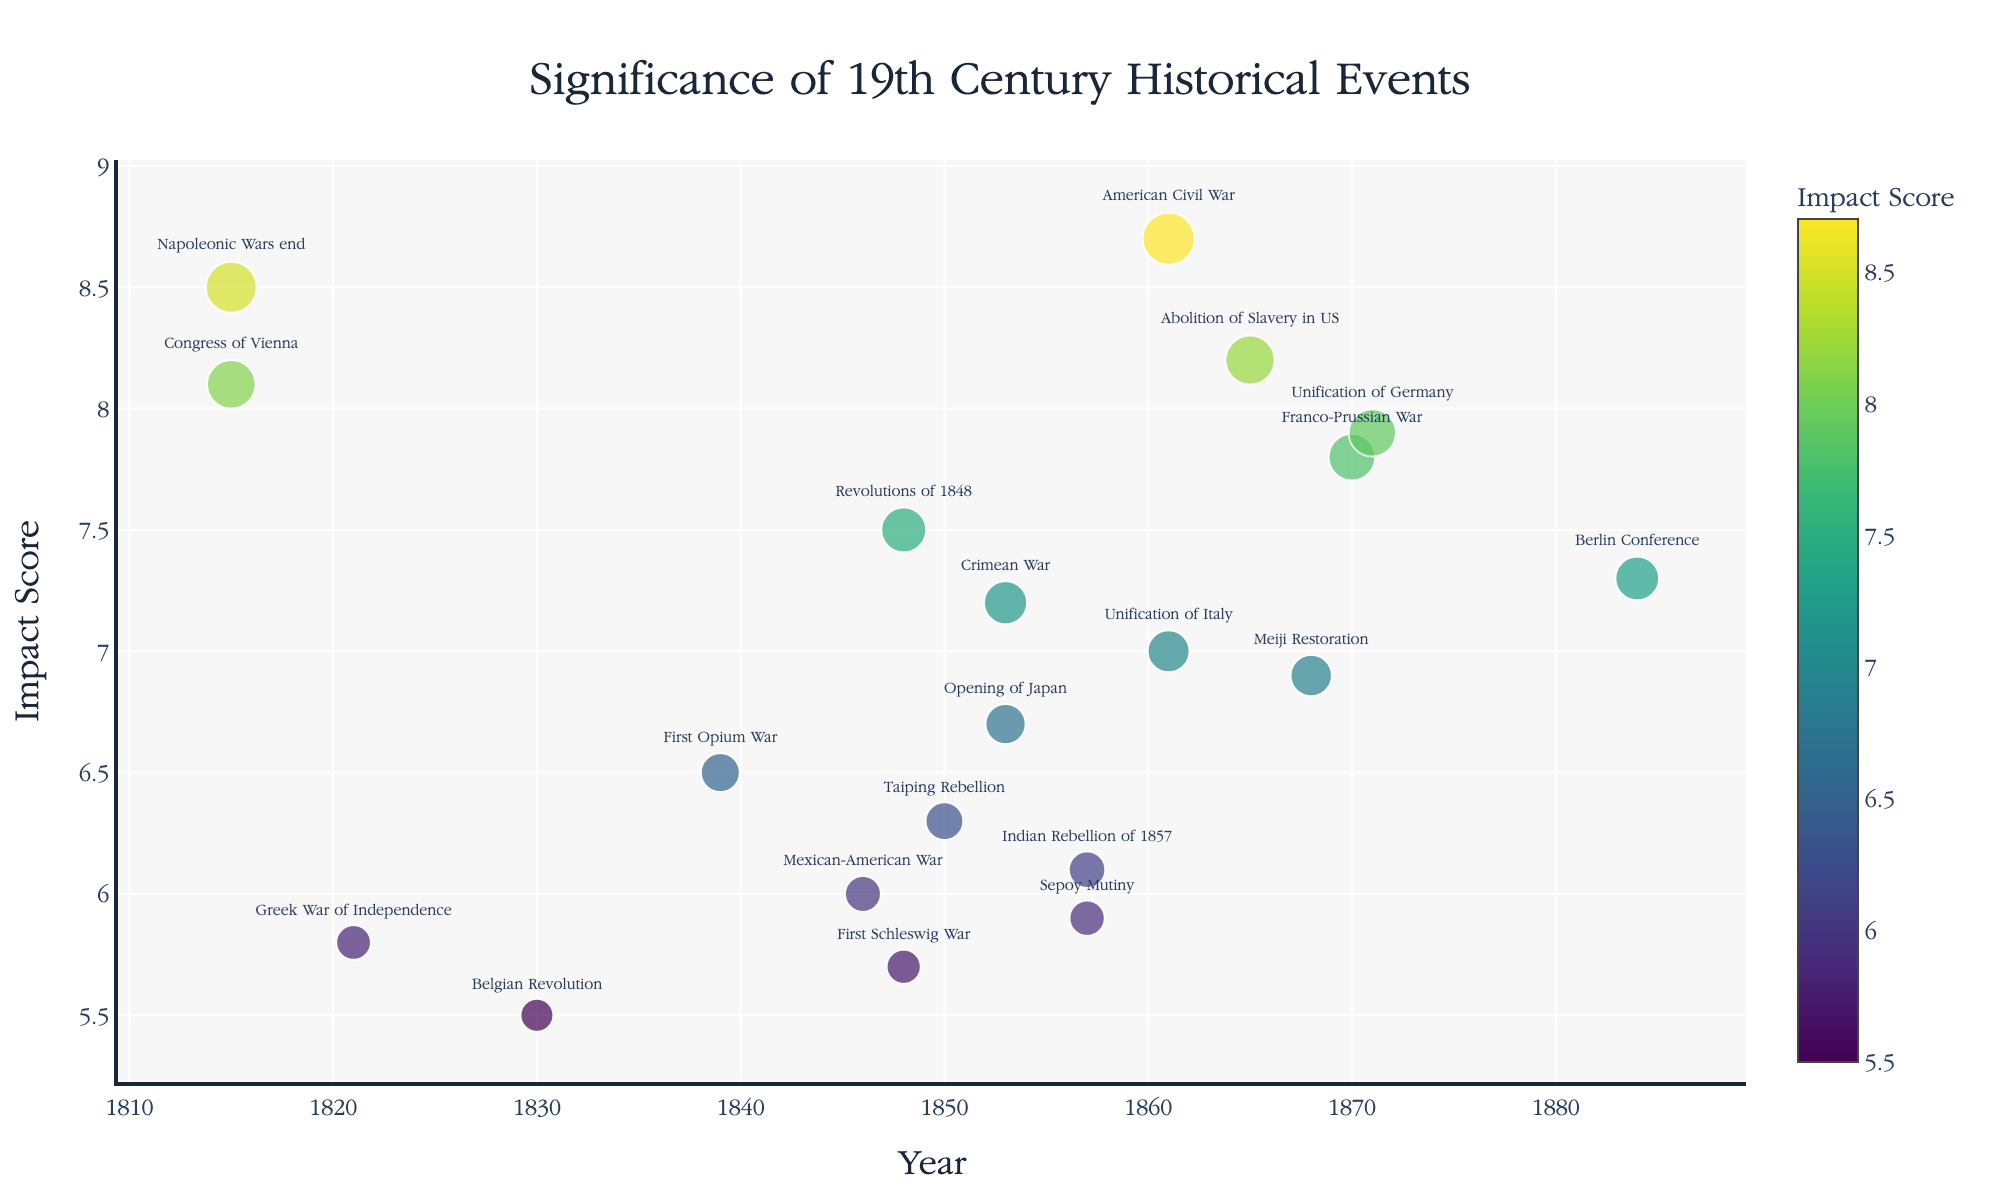What's the title of the plot? The title is usually displayed at the top of the plot in larger font size.
Answer: Significance of 19th Century Historical Events Which event has the highest impact score in the 19th century? Find the highest point on the y-axis which represents the highest impact score, and check the event label.
Answer: American Civil War How many historical events occurred between 1850 and 1860? Look at the x-axis, identify events with years in that range, and count them.
Answer: 3 Which two events have the smallest impact scores, and what are those scores? Identify the lowest points on the y-axis and read their event labels and corresponding scores.
Answer: Belgian Revolution (5.5) and First Schleswig War (5.7) Which event in the 1860s had the second highest impact score, and what was that score? Find the events in the 1860s (1860-1869) and compare their impact scores to determine the second highest.
Answer: Abolition of Slavery in US (8.2) Which event had an impact score closest to the average impact score, and what is that event? Calculate the average impact score, then find the event with a score closest to this average.
Answer: Unification of Italy (7.0) How does the impact of the American Civil War compare to the Napoleonic Wars' end? Compare their positions on the y-axis, where higher y-values indicate higher impact scores.
Answer: The American Civil War has a higher impact score than the Napoleonic Wars' end How many events on the plot have an impact score greater than 7.0? Count all events with y-axis values above 7.0.
Answer: 8 Which event in the 1850s had the highest impact, and what was the score? Check all events between 1850 and 1859, comparing their y-axis positions to find the highest score.
Answer: Crimean War (7.2) 